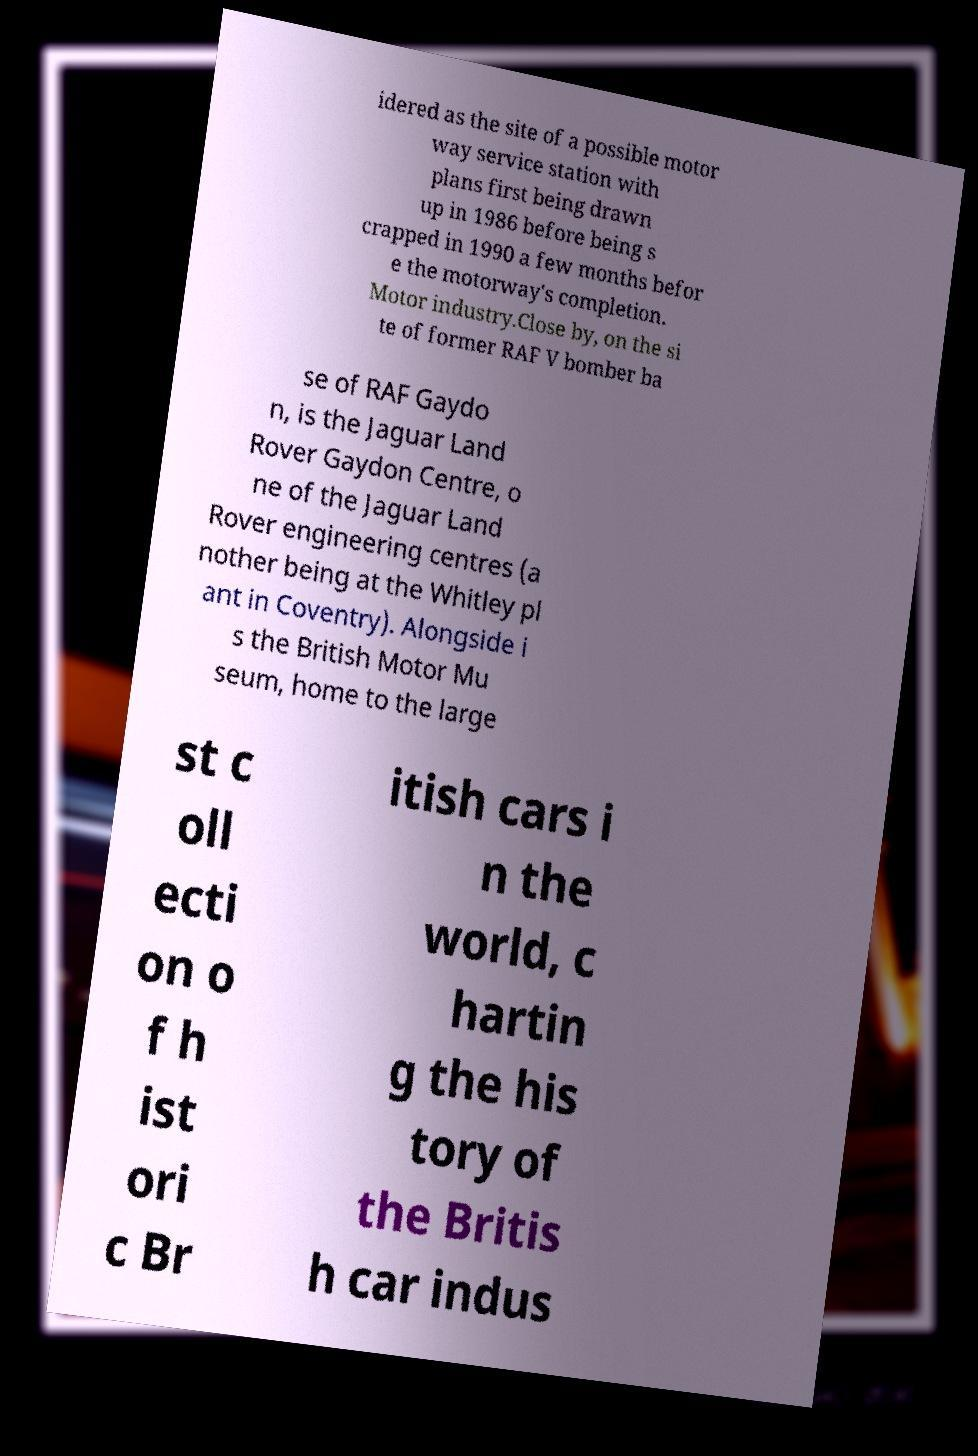Could you extract and type out the text from this image? idered as the site of a possible motor way service station with plans first being drawn up in 1986 before being s crapped in 1990 a few months befor e the motorway's completion. Motor industry.Close by, on the si te of former RAF V bomber ba se of RAF Gaydo n, is the Jaguar Land Rover Gaydon Centre, o ne of the Jaguar Land Rover engineering centres (a nother being at the Whitley pl ant in Coventry). Alongside i s the British Motor Mu seum, home to the large st c oll ecti on o f h ist ori c Br itish cars i n the world, c hartin g the his tory of the Britis h car indus 